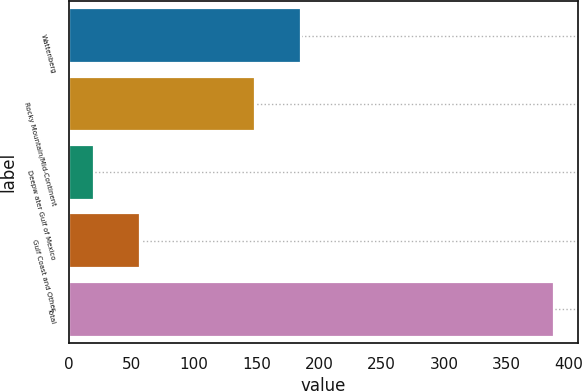<chart> <loc_0><loc_0><loc_500><loc_500><bar_chart><fcel>Wattenberg<fcel>Rocky Mountain/Mid-Continent<fcel>Deepw ater Gulf of Mexico<fcel>Gulf Coast and Other<fcel>Total<nl><fcel>185.8<fcel>149<fcel>20<fcel>56.8<fcel>388<nl></chart> 